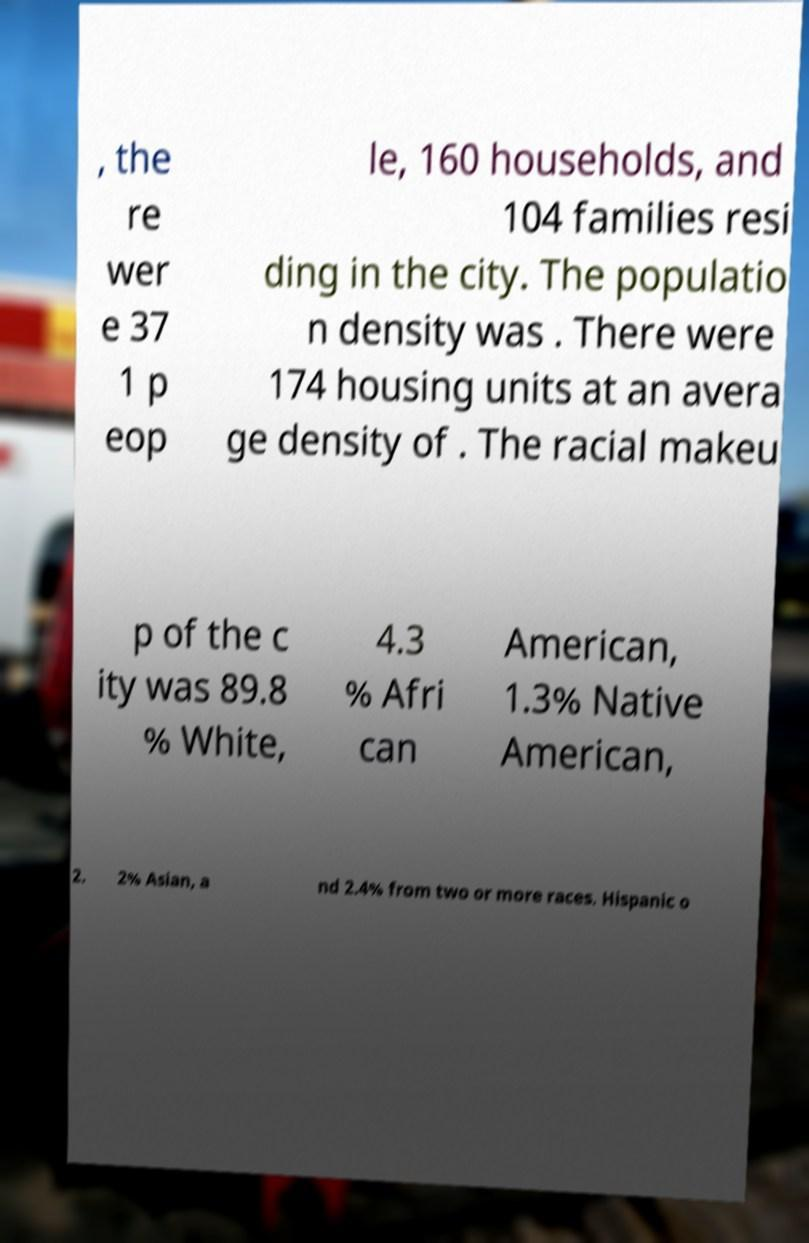Can you read and provide the text displayed in the image?This photo seems to have some interesting text. Can you extract and type it out for me? , the re wer e 37 1 p eop le, 160 households, and 104 families resi ding in the city. The populatio n density was . There were 174 housing units at an avera ge density of . The racial makeu p of the c ity was 89.8 % White, 4.3 % Afri can American, 1.3% Native American, 2. 2% Asian, a nd 2.4% from two or more races. Hispanic o 